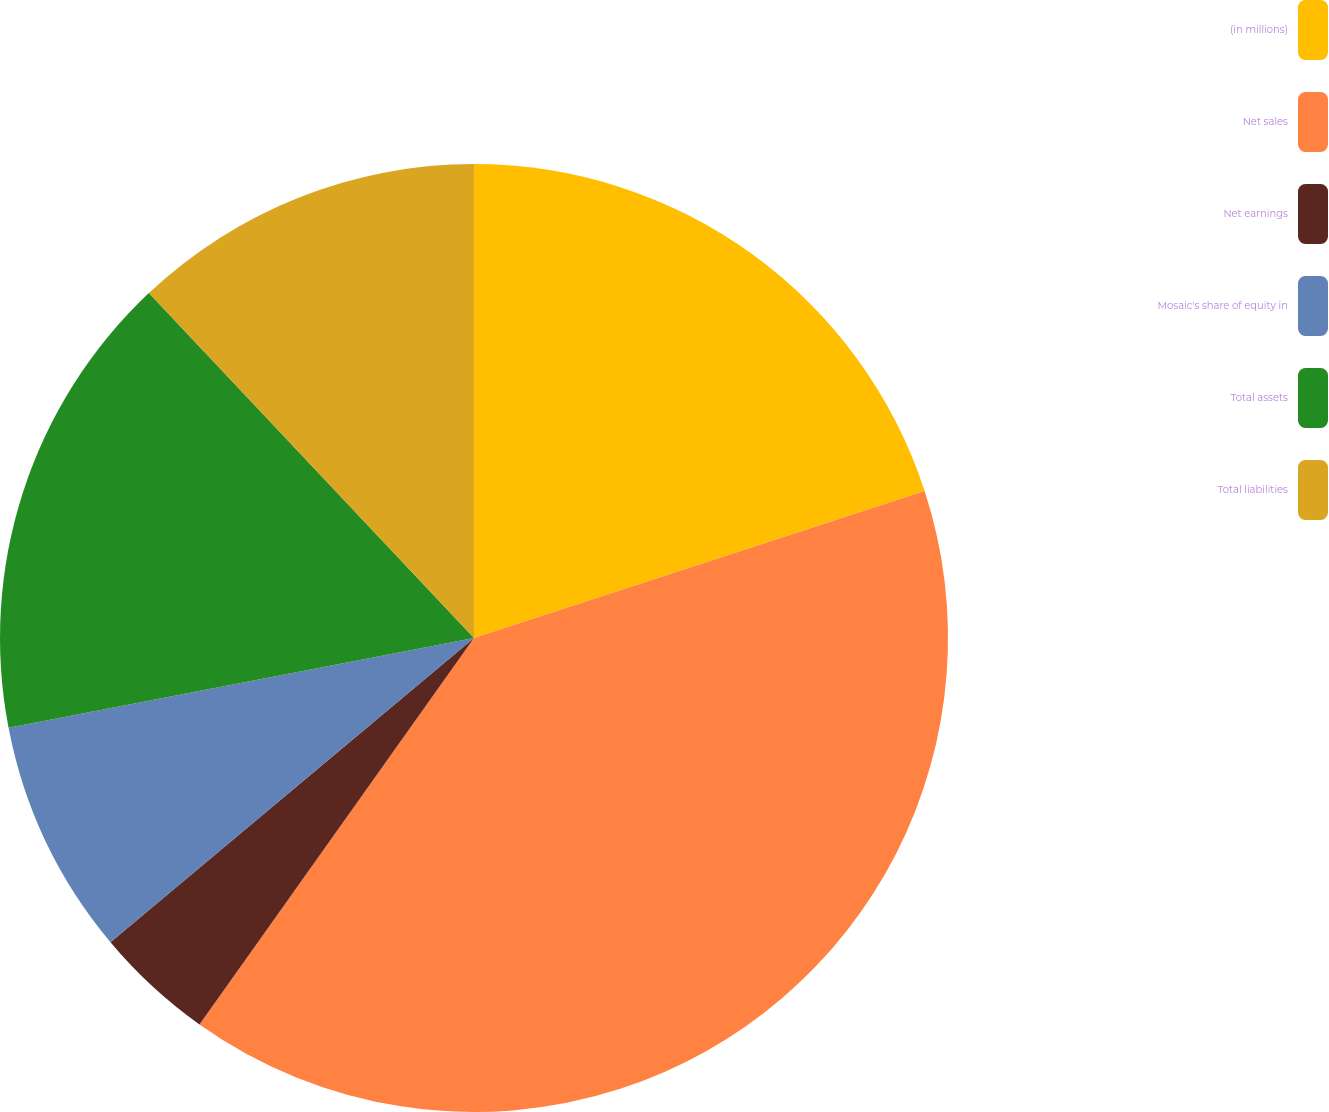<chart> <loc_0><loc_0><loc_500><loc_500><pie_chart><fcel>(in millions)<fcel>Net sales<fcel>Net earnings<fcel>Mosaic's share of equity in<fcel>Total assets<fcel>Total liabilities<nl><fcel>19.98%<fcel>39.85%<fcel>4.08%<fcel>8.06%<fcel>16.0%<fcel>12.03%<nl></chart> 